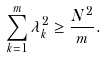<formula> <loc_0><loc_0><loc_500><loc_500>\sum _ { k = 1 } ^ { m } \lambda _ { k } ^ { 2 } \geq \frac { N ^ { 2 } } { m } .</formula> 